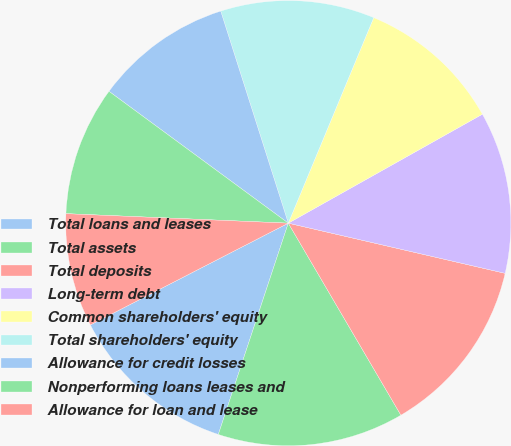Convert chart to OTSL. <chart><loc_0><loc_0><loc_500><loc_500><pie_chart><fcel>Total loans and leases<fcel>Total assets<fcel>Total deposits<fcel>Long-term debt<fcel>Common shareholders' equity<fcel>Total shareholders' equity<fcel>Allowance for credit losses<fcel>Nonperforming loans leases and<fcel>Allowance for loan and lease<nl><fcel>12.35%<fcel>13.53%<fcel>12.94%<fcel>11.76%<fcel>10.59%<fcel>11.18%<fcel>10.0%<fcel>9.41%<fcel>8.24%<nl></chart> 